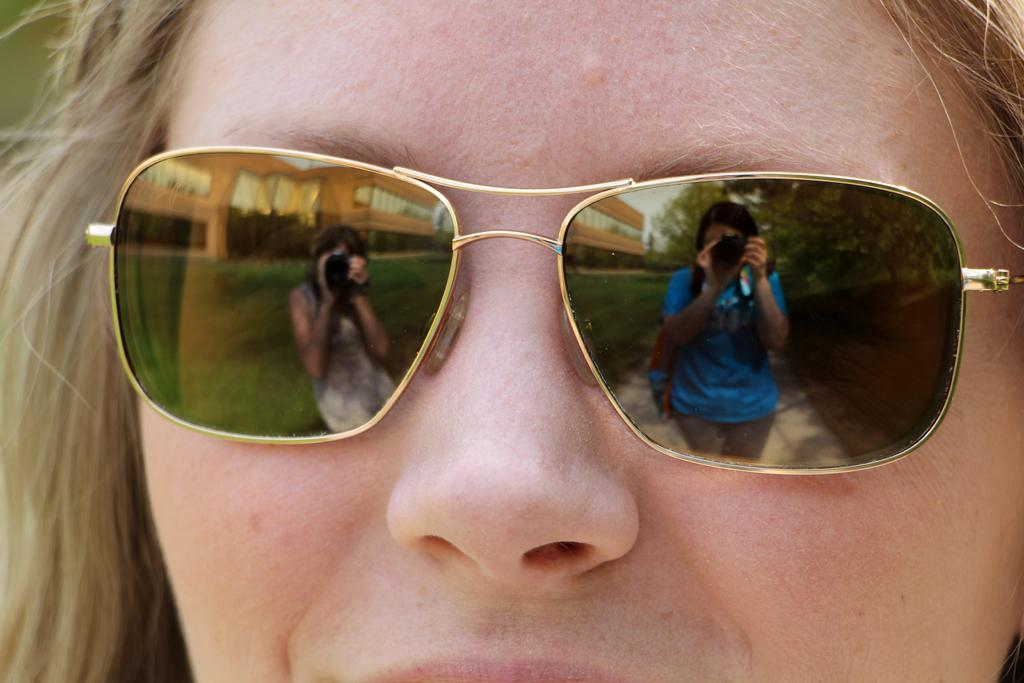Who is present in the image? There is a woman in the image. What is the woman wearing on her face? The woman is wearing goggles. What can be seen in the lens of the goggles? The lens of the goggles has a visible reflection. How many cannons are visible in the image? There are no cannons present in the image. What type of shoes is the woman wearing in the image? The provided facts do not mention the woman's shoes, so we cannot determine the type of shoes she is wearing. 